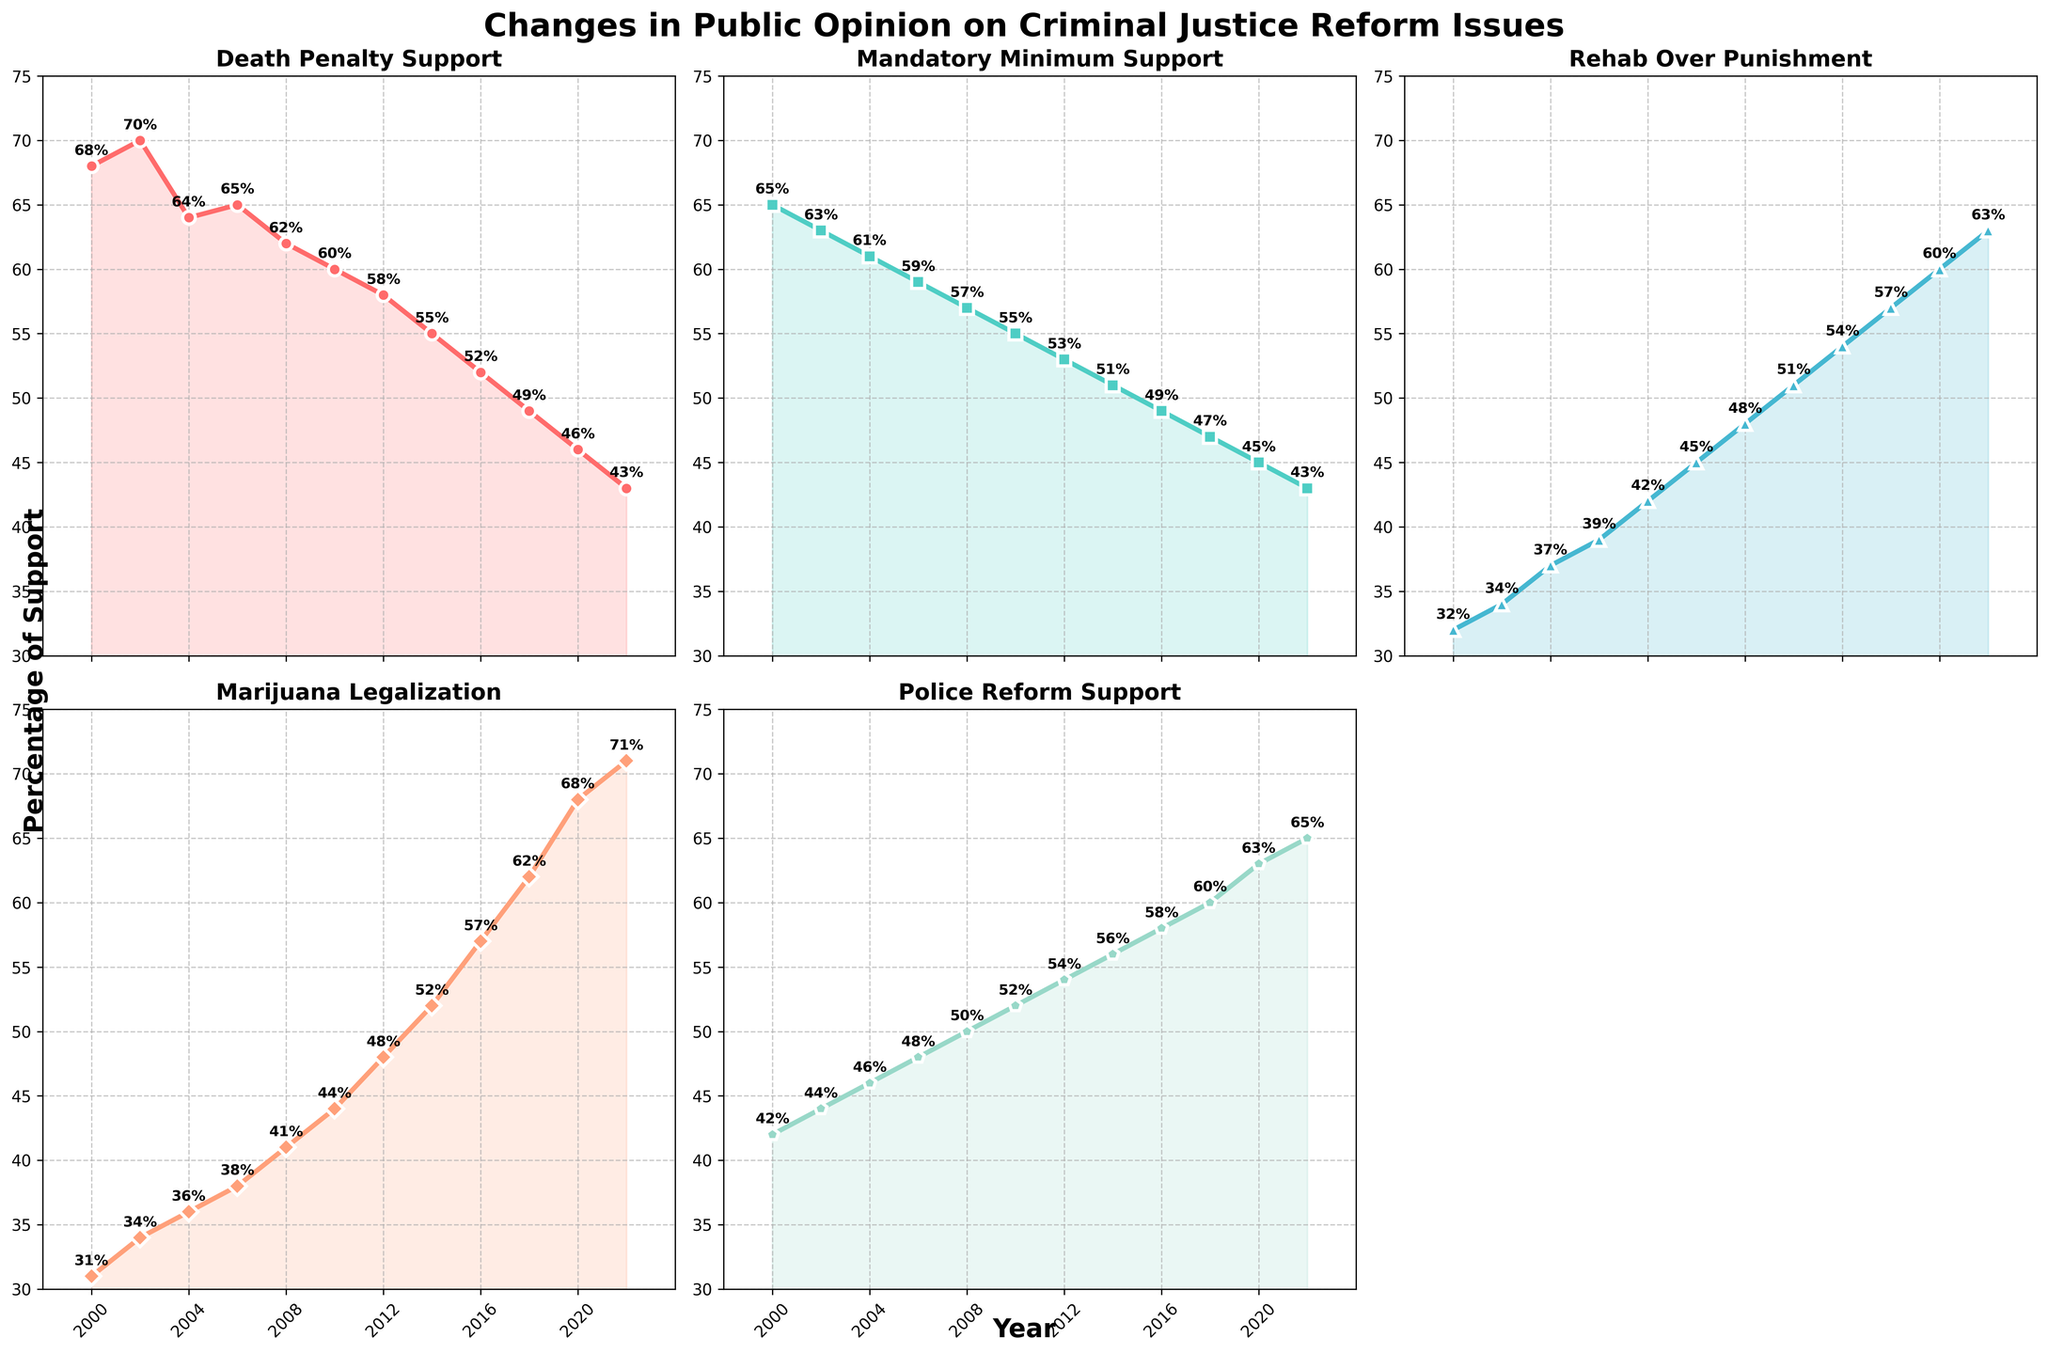How did the support for the death penalty change from 2000 to 2022? In 2000, support for the death penalty was 68%. By 2022, it had dropped to 43%. This is a decrease of 25 percentage points over the 22-year period.
Answer: It decreased by 25 percentage points Which year shows the lowest support for mandatory minimum sentences, and what is the percentage? By examining the line for mandatory minimum support, the lowest point occurs in 2022, where the percentage is 43%.
Answer: 2022, 43% Between which two consecutive years did support for marijuana legalization increase the most? After examining the line plot for marijuana legalization, the largest increase occurred between 2018 and 2020, where support rose from 62% to 68%, a 6 percentage point increase.
Answer: 2018 to 2020 What trend can be observed in the support for police reform from 2000 to 2022? The support for police reform steadily increased from 42% in 2000 to 65% in 2022, showing a general upward trend over the years.
Answer: It consistently increased What aspect (e.g., death penalty, mandatory minimum sentences) had the highest support in 2000, and what was the percentage? In 2000, the death penalty had the highest support at 68%, compared to the other aspects which had lower percentages.
Answer: Death penalty, 68% Which reform issue had the highest increase in support from 2000 to 2022? By comparing the endpoints of each line from the year 2000 to 2022, marijuana legalization support increased the most, from 31% to 71%, a total of 40 percentage points.
Answer: Marijuana legalization, 40 points Compare the support for rehabilitation over punishment in 2006 and 2016. Which year had higher support and by how much? In 2006, the support for rehabilitation over punishment was 39%. In 2016, it was 54%. Thus, 2016 had higher support by 15 percentage points.
Answer: 2016, by 15 percentage points If you average the public support for police reform in every year shown, what is the result? To find the average, sum up all the percentages for police reform from 2000 to 2022 (42 + 44 + 46 + 48 + 50 + 52 + 54 + 56 + 58 + 60 + 63 + 65 = 638) and divide by the number of years (12). The calculation is 638 / 12 = 53.17.
Answer: 53.17% What years had the same level of support for mandatory minimum sentences and what was the percentage? The line chart shows that years 2000 and 2002 had 65% and 63%, respectively. The closest same level occurred for years 2004 (61%) and 2006 (59%).
Answer: None exactly the same for 43%; Closest: 2004 and 2006 Does the support for any issue experience a decrease between 2010 and 2012? By examining each line between 2010 and 2012, only the death penalty support (60% to 58%) and mandatory minimum sentences (55% to 53%) show a slight decrease.
Answer: Death penalty and mandatory minimum sentences both decreased 